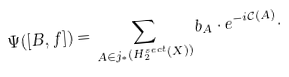<formula> <loc_0><loc_0><loc_500><loc_500>\Psi ( [ B , f ] ) = \sum _ { { A } \in j _ { * } ( H _ { 2 } ^ { s e c t } ( X ) ) } b _ { A } \cdot e ^ { - i \mathcal { C } ( { A } ) } .</formula> 